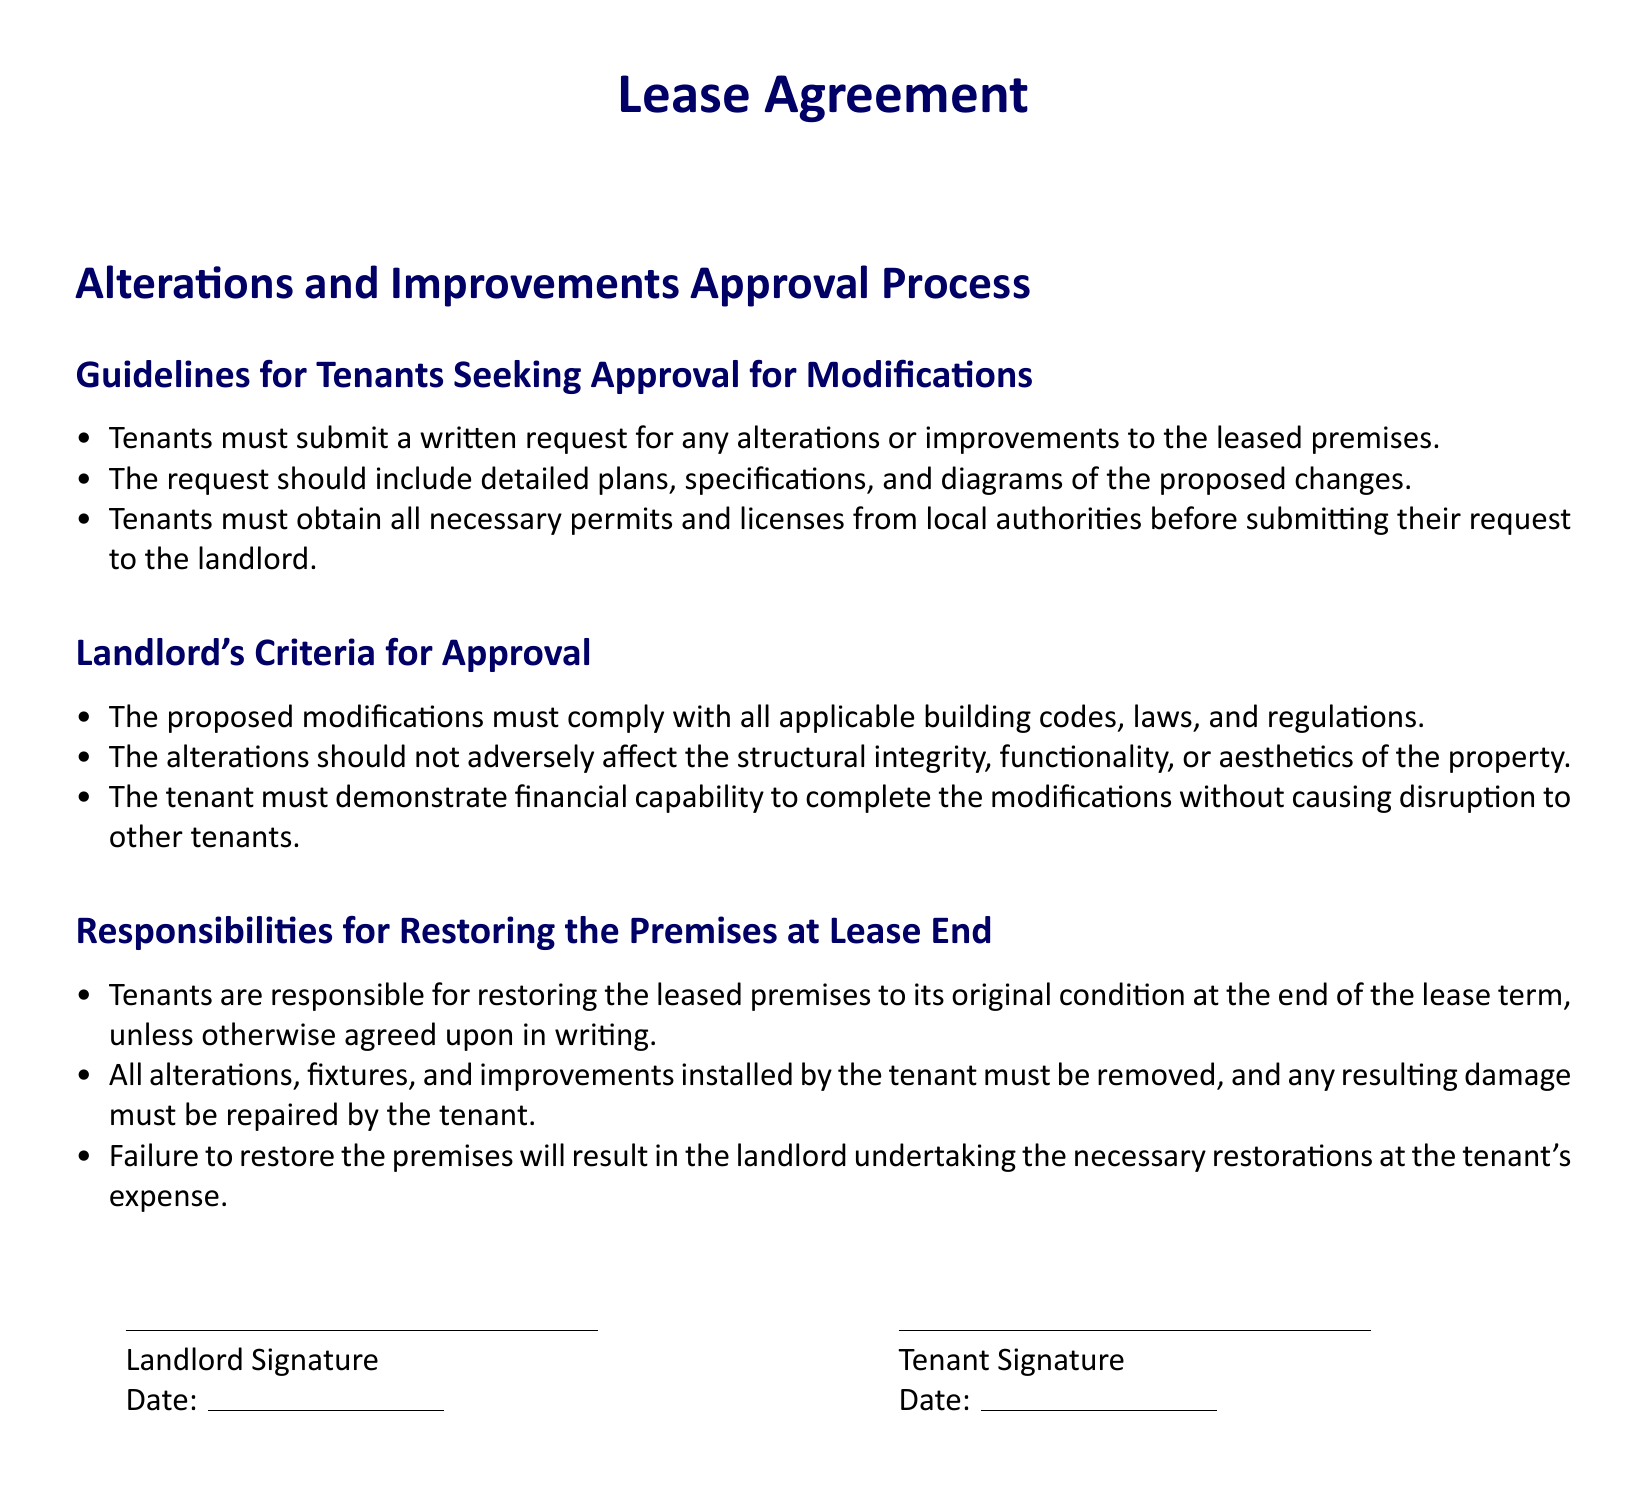What must tenants submit for alterations? Tenants must submit a written request for any alterations or improvements to the leased premises.
Answer: Written request What do tenants need to include in their alteration request? The request should include detailed plans, specifications, and diagrams of the proposed changes.
Answer: Detailed plans What is the landlord's first criterion for approval? The proposed modifications must comply with all applicable building codes, laws, and regulations.
Answer: Compliance with building codes What happens if tenants fail to restore the premises? Failure to restore the premises will result in the landlord undertaking the necessary restorations at the tenant's expense.
Answer: Tenant's expense When must tenants obtain necessary permits? Tenants must obtain all necessary permits and licenses from local authorities before submitting their request to the landlord.
Answer: Before request submission 